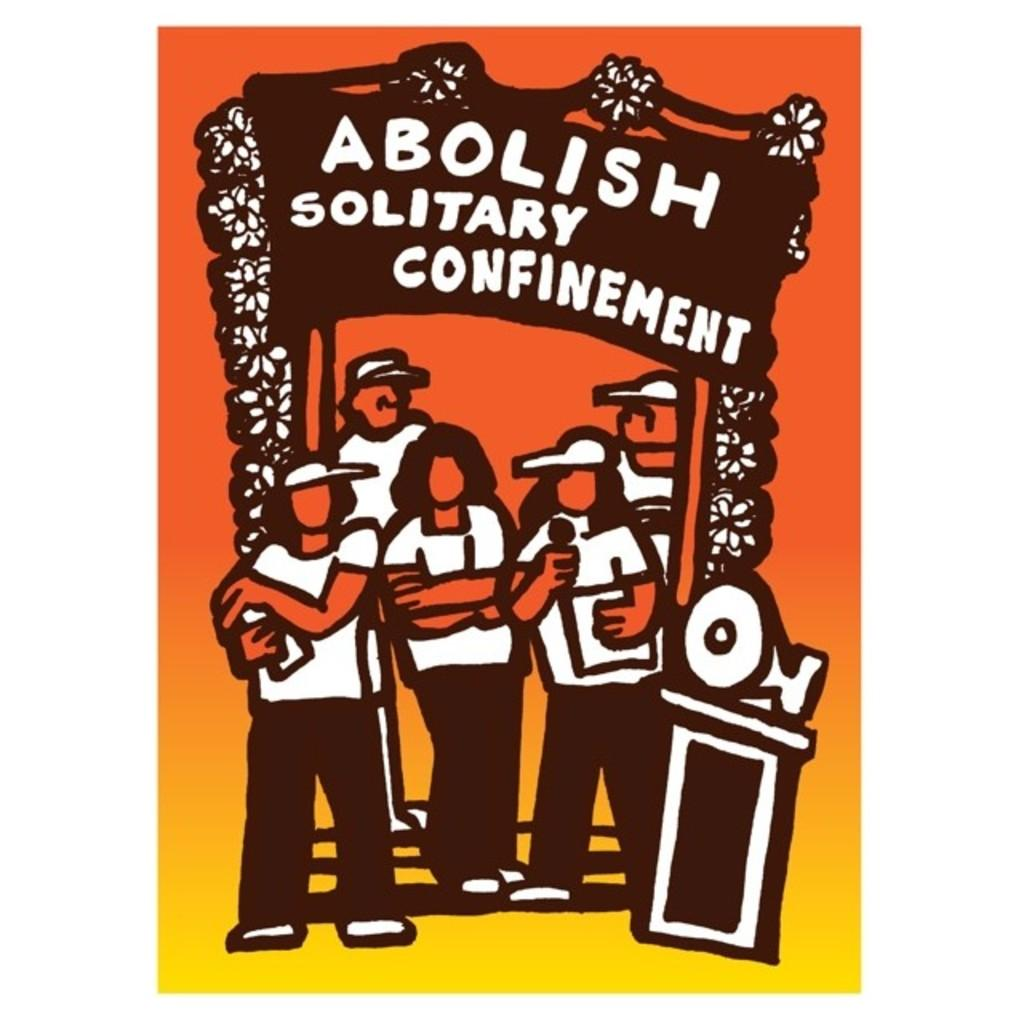<image>
Share a concise interpretation of the image provided. Abolish Solitary Confinement is on a sign in yellow. 